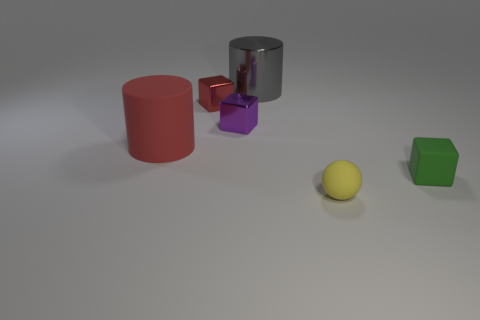Is the material of the red cylinder the same as the cylinder to the right of the big red cylinder?
Your answer should be compact. No. There is a tiny object right of the tiny rubber thing on the left side of the cube that is on the right side of the big gray metallic cylinder; what color is it?
Ensure brevity in your answer.  Green. Are there any other things that have the same shape as the small yellow matte thing?
Offer a terse response. No. Are there more tiny purple objects than shiny blocks?
Ensure brevity in your answer.  No. How many things are both in front of the small green object and behind the green rubber object?
Your response must be concise. 0. There is a tiny metallic block behind the tiny purple thing; what number of large things are on the right side of it?
Give a very brief answer. 1. Do the rubber object that is in front of the small green object and the matte object that is on the left side of the tiny yellow rubber thing have the same size?
Give a very brief answer. No. What number of rubber objects are there?
Offer a very short reply. 3. How many big red cylinders have the same material as the yellow ball?
Provide a succinct answer. 1. Are there the same number of big cylinders in front of the big metal cylinder and small red rubber spheres?
Your response must be concise. No. 